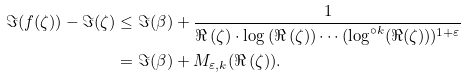<formula> <loc_0><loc_0><loc_500><loc_500>\Im ( f ( \zeta ) ) - \Im ( \zeta ) & \leq \Im ( \beta ) + \frac { 1 } { \Re \left ( \zeta \right ) \cdot \log \left ( \Re \left ( \zeta \right ) \right ) \cdots ( \log ^ { \circ k } ( \Re ( \zeta ) ) ) ^ { 1 + \varepsilon } } \\ & = \Im ( \beta ) + M _ { \varepsilon , k } ( \Re \left ( \zeta \right ) ) .</formula> 